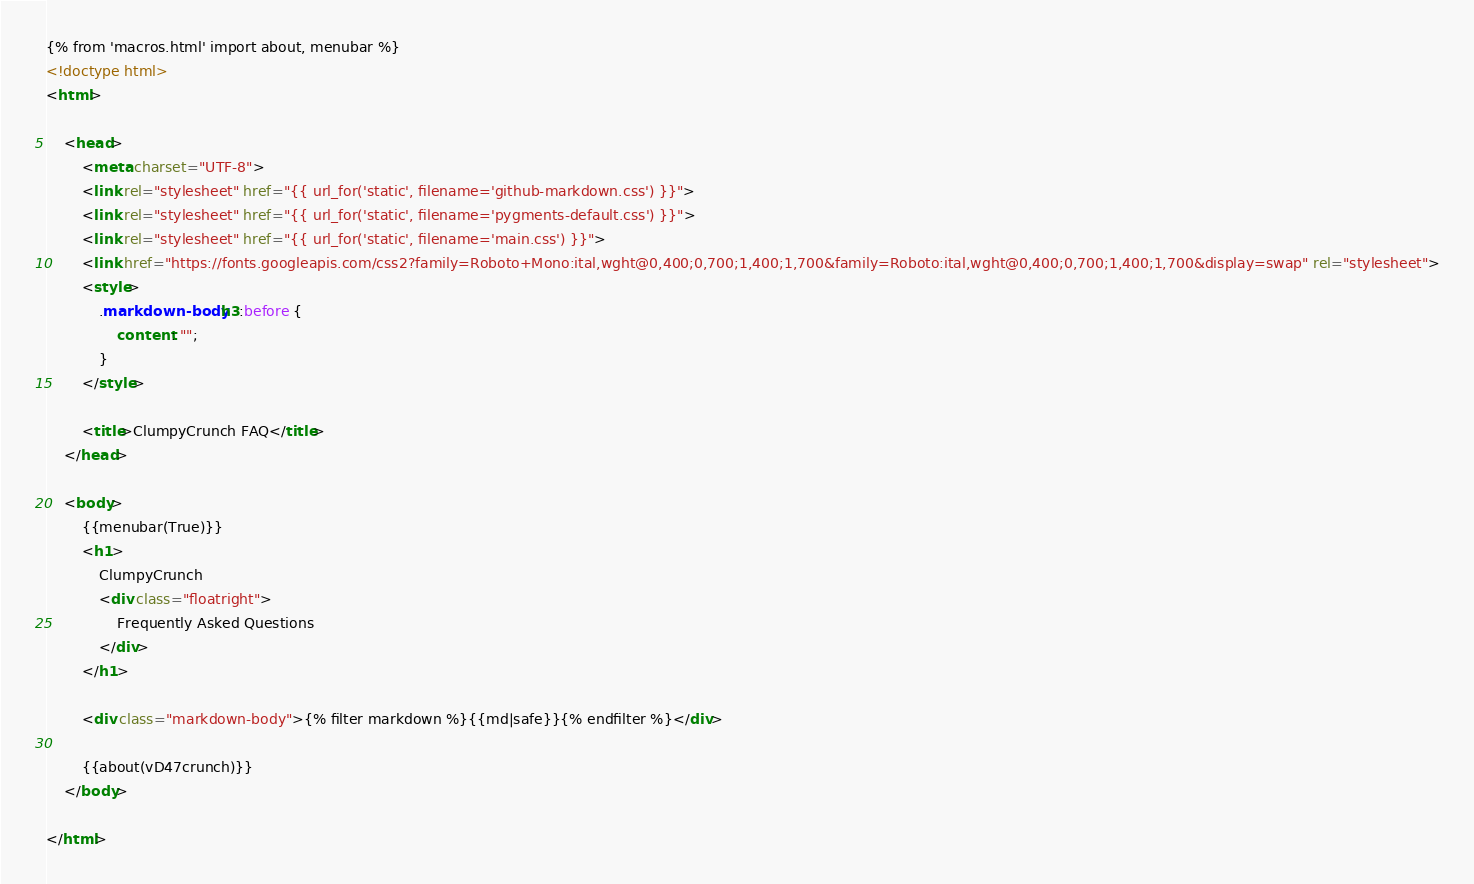<code> <loc_0><loc_0><loc_500><loc_500><_HTML_>{% from 'macros.html' import about, menubar %}
<!doctype html>
<html>

	<head>
		<meta charset="UTF-8">
		<link rel="stylesheet" href="{{ url_for('static', filename='github-markdown.css') }}">
		<link rel="stylesheet" href="{{ url_for('static', filename='pygments-default.css') }}">
		<link rel="stylesheet" href="{{ url_for('static', filename='main.css') }}">
		<link href="https://fonts.googleapis.com/css2?family=Roboto+Mono:ital,wght@0,400;0,700;1,400;1,700&family=Roboto:ital,wght@0,400;0,700;1,400;1,700&display=swap" rel="stylesheet">
		<style>
			.markdown-body h3:before {
				content: "";
			}
		</style>

		<title>ClumpyCrunch FAQ</title>
	</head>

	<body>
		{{menubar(True)}}
		<h1>
			ClumpyCrunch
			<div class="floatright">
				Frequently Asked Questions
			</div>
		</h1>

		<div class="markdown-body">{% filter markdown %}{{md|safe}}{% endfilter %}</div>

		{{about(vD47crunch)}}
	</body>

</html>
</code> 